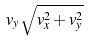Convert formula to latex. <formula><loc_0><loc_0><loc_500><loc_500>v _ { y } \sqrt { v _ { x } ^ { 2 } + v _ { y } ^ { 2 } }</formula> 